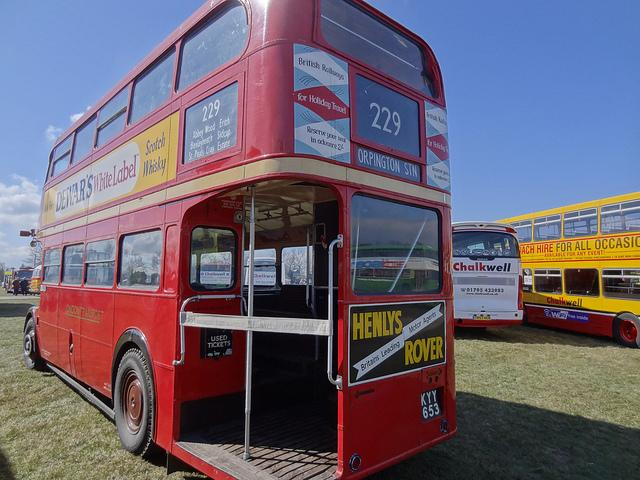What number is closest to the number at the top of the bus? Please explain your reasoning. 240. The number at the top of the bus is 229. 